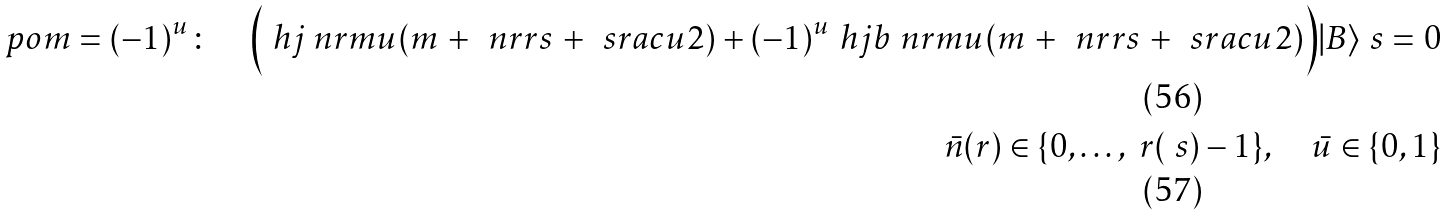Convert formula to latex. <formula><loc_0><loc_0><loc_500><loc_500>\ p o m = ( - 1 ) ^ { u } \colon \quad \Big { ( } \ h j _ { \ } n r m u ( m \, + \, \ n r r s \, + \, \ s r a c { u } { 2 } ) + ( - 1 ) ^ { u } \ h j b _ { \ } n r m u ( m \, + \, \ n r r s \, + \, \ s r a c { u } { 2 } ) \Big { ) } | B \rangle _ { \ } s = 0 \\ \bar { n } ( r ) \in \{ 0 , \dots , \ r ( \ s ) - 1 \} , \quad \bar { u } \in \{ 0 , 1 \}</formula> 